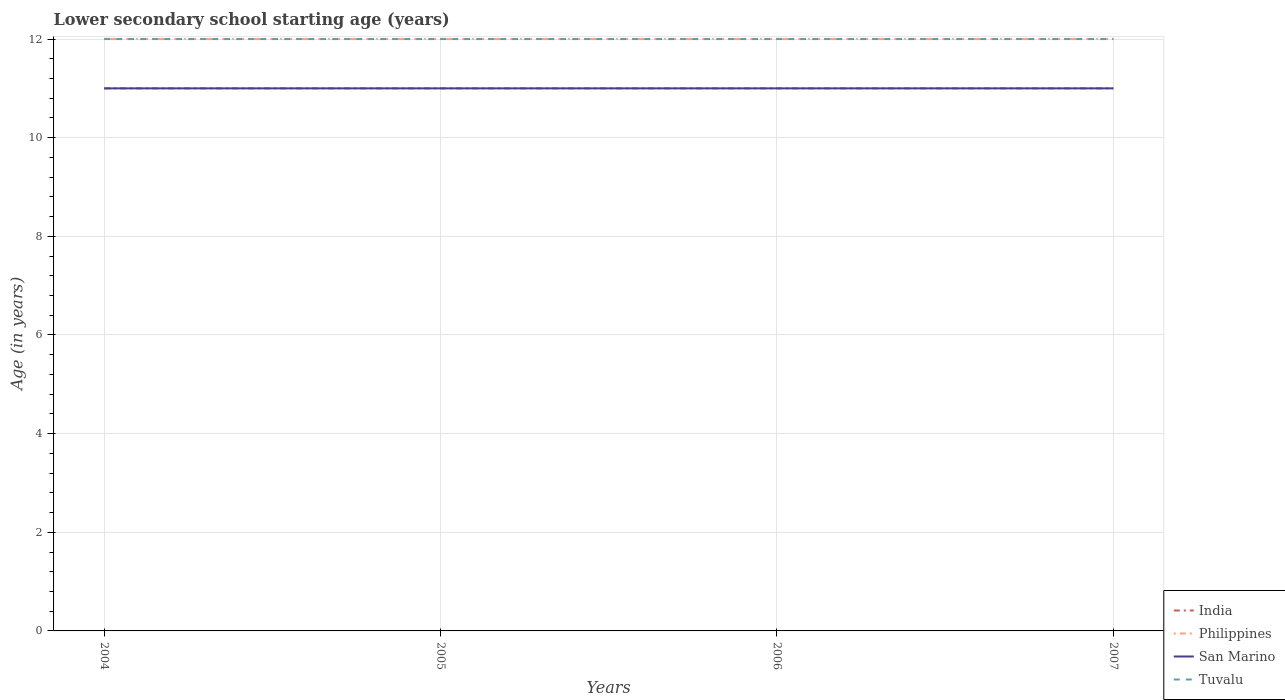How many different coloured lines are there?
Keep it short and to the point. 4. Is the number of lines equal to the number of legend labels?
Ensure brevity in your answer.  Yes. Across all years, what is the maximum lower secondary school starting age of children in India?
Make the answer very short. 11. What is the difference between the highest and the second highest lower secondary school starting age of children in San Marino?
Offer a terse response. 0. What is the difference between the highest and the lowest lower secondary school starting age of children in Tuvalu?
Give a very brief answer. 0. What is the difference between two consecutive major ticks on the Y-axis?
Your answer should be compact. 2. Does the graph contain grids?
Offer a very short reply. Yes. Where does the legend appear in the graph?
Provide a short and direct response. Bottom right. How many legend labels are there?
Your answer should be compact. 4. How are the legend labels stacked?
Provide a short and direct response. Vertical. What is the title of the graph?
Make the answer very short. Lower secondary school starting age (years). What is the label or title of the Y-axis?
Ensure brevity in your answer.  Age (in years). What is the Age (in years) in San Marino in 2004?
Offer a terse response. 11. What is the Age (in years) of Tuvalu in 2004?
Offer a very short reply. 12. What is the Age (in years) in Philippines in 2005?
Your answer should be compact. 12. What is the Age (in years) of India in 2006?
Provide a succinct answer. 11. What is the Age (in years) of Tuvalu in 2006?
Keep it short and to the point. 12. What is the Age (in years) of San Marino in 2007?
Provide a succinct answer. 11. What is the Age (in years) in Tuvalu in 2007?
Your answer should be very brief. 12. Across all years, what is the maximum Age (in years) of San Marino?
Make the answer very short. 11. Across all years, what is the maximum Age (in years) in Tuvalu?
Keep it short and to the point. 12. What is the total Age (in years) of India in the graph?
Ensure brevity in your answer.  44. What is the difference between the Age (in years) of India in 2004 and that in 2005?
Keep it short and to the point. 0. What is the difference between the Age (in years) in Philippines in 2004 and that in 2005?
Provide a short and direct response. 0. What is the difference between the Age (in years) of India in 2004 and that in 2006?
Your answer should be compact. 0. What is the difference between the Age (in years) in San Marino in 2004 and that in 2006?
Provide a short and direct response. 0. What is the difference between the Age (in years) in Philippines in 2004 and that in 2007?
Offer a terse response. 0. What is the difference between the Age (in years) in Tuvalu in 2004 and that in 2007?
Offer a terse response. 0. What is the difference between the Age (in years) of India in 2005 and that in 2006?
Offer a terse response. 0. What is the difference between the Age (in years) of Tuvalu in 2005 and that in 2006?
Provide a succinct answer. 0. What is the difference between the Age (in years) of Philippines in 2005 and that in 2007?
Provide a succinct answer. 0. What is the difference between the Age (in years) of Philippines in 2006 and that in 2007?
Your answer should be compact. 0. What is the difference between the Age (in years) of San Marino in 2006 and that in 2007?
Keep it short and to the point. 0. What is the difference between the Age (in years) of Tuvalu in 2006 and that in 2007?
Keep it short and to the point. 0. What is the difference between the Age (in years) of Philippines in 2004 and the Age (in years) of San Marino in 2005?
Your answer should be very brief. 1. What is the difference between the Age (in years) of Philippines in 2004 and the Age (in years) of Tuvalu in 2005?
Provide a short and direct response. 0. What is the difference between the Age (in years) of San Marino in 2004 and the Age (in years) of Tuvalu in 2005?
Your answer should be compact. -1. What is the difference between the Age (in years) of India in 2004 and the Age (in years) of Philippines in 2006?
Provide a succinct answer. -1. What is the difference between the Age (in years) of India in 2004 and the Age (in years) of San Marino in 2006?
Your answer should be compact. 0. What is the difference between the Age (in years) of Philippines in 2004 and the Age (in years) of Tuvalu in 2006?
Provide a succinct answer. 0. What is the difference between the Age (in years) in India in 2004 and the Age (in years) in Tuvalu in 2007?
Keep it short and to the point. -1. What is the difference between the Age (in years) in Philippines in 2004 and the Age (in years) in San Marino in 2007?
Your response must be concise. 1. What is the difference between the Age (in years) of India in 2005 and the Age (in years) of Philippines in 2006?
Ensure brevity in your answer.  -1. What is the difference between the Age (in years) of India in 2005 and the Age (in years) of San Marino in 2006?
Provide a succinct answer. 0. What is the difference between the Age (in years) in India in 2005 and the Age (in years) in Tuvalu in 2006?
Make the answer very short. -1. What is the difference between the Age (in years) in Philippines in 2005 and the Age (in years) in Tuvalu in 2006?
Keep it short and to the point. 0. What is the difference between the Age (in years) of India in 2005 and the Age (in years) of San Marino in 2007?
Ensure brevity in your answer.  0. What is the difference between the Age (in years) of San Marino in 2005 and the Age (in years) of Tuvalu in 2007?
Your answer should be compact. -1. What is the difference between the Age (in years) in India in 2006 and the Age (in years) in Philippines in 2007?
Ensure brevity in your answer.  -1. What is the difference between the Age (in years) in India in 2006 and the Age (in years) in Tuvalu in 2007?
Your response must be concise. -1. What is the difference between the Age (in years) in Philippines in 2006 and the Age (in years) in San Marino in 2007?
Keep it short and to the point. 1. What is the difference between the Age (in years) of Philippines in 2006 and the Age (in years) of Tuvalu in 2007?
Your response must be concise. 0. What is the difference between the Age (in years) in San Marino in 2006 and the Age (in years) in Tuvalu in 2007?
Provide a succinct answer. -1. What is the average Age (in years) of India per year?
Ensure brevity in your answer.  11. What is the average Age (in years) of San Marino per year?
Your answer should be very brief. 11. In the year 2004, what is the difference between the Age (in years) of India and Age (in years) of Philippines?
Offer a very short reply. -1. In the year 2004, what is the difference between the Age (in years) of Philippines and Age (in years) of Tuvalu?
Keep it short and to the point. 0. In the year 2004, what is the difference between the Age (in years) of San Marino and Age (in years) of Tuvalu?
Give a very brief answer. -1. In the year 2005, what is the difference between the Age (in years) of India and Age (in years) of Tuvalu?
Make the answer very short. -1. In the year 2005, what is the difference between the Age (in years) of Philippines and Age (in years) of San Marino?
Keep it short and to the point. 1. In the year 2005, what is the difference between the Age (in years) in San Marino and Age (in years) in Tuvalu?
Provide a succinct answer. -1. In the year 2006, what is the difference between the Age (in years) in India and Age (in years) in San Marino?
Offer a terse response. 0. In the year 2006, what is the difference between the Age (in years) in India and Age (in years) in Tuvalu?
Your answer should be compact. -1. In the year 2006, what is the difference between the Age (in years) in Philippines and Age (in years) in San Marino?
Your answer should be compact. 1. In the year 2006, what is the difference between the Age (in years) in San Marino and Age (in years) in Tuvalu?
Provide a succinct answer. -1. In the year 2007, what is the difference between the Age (in years) of India and Age (in years) of San Marino?
Your response must be concise. 0. In the year 2007, what is the difference between the Age (in years) of India and Age (in years) of Tuvalu?
Ensure brevity in your answer.  -1. In the year 2007, what is the difference between the Age (in years) of Philippines and Age (in years) of San Marino?
Your answer should be compact. 1. What is the ratio of the Age (in years) of India in 2004 to that in 2005?
Provide a short and direct response. 1. What is the ratio of the Age (in years) of San Marino in 2004 to that in 2005?
Give a very brief answer. 1. What is the ratio of the Age (in years) in Tuvalu in 2004 to that in 2005?
Ensure brevity in your answer.  1. What is the ratio of the Age (in years) in India in 2004 to that in 2006?
Give a very brief answer. 1. What is the ratio of the Age (in years) of San Marino in 2004 to that in 2006?
Provide a succinct answer. 1. What is the ratio of the Age (in years) of Philippines in 2004 to that in 2007?
Your answer should be compact. 1. What is the ratio of the Age (in years) in San Marino in 2004 to that in 2007?
Your answer should be compact. 1. What is the ratio of the Age (in years) in Tuvalu in 2004 to that in 2007?
Offer a terse response. 1. What is the ratio of the Age (in years) of India in 2005 to that in 2006?
Ensure brevity in your answer.  1. What is the ratio of the Age (in years) in Philippines in 2005 to that in 2006?
Offer a very short reply. 1. What is the ratio of the Age (in years) of San Marino in 2005 to that in 2006?
Provide a short and direct response. 1. What is the ratio of the Age (in years) of Tuvalu in 2005 to that in 2006?
Your answer should be very brief. 1. What is the ratio of the Age (in years) in India in 2005 to that in 2007?
Offer a terse response. 1. What is the ratio of the Age (in years) in Tuvalu in 2005 to that in 2007?
Offer a terse response. 1. What is the ratio of the Age (in years) of India in 2006 to that in 2007?
Provide a short and direct response. 1. What is the difference between the highest and the second highest Age (in years) of India?
Your response must be concise. 0. What is the difference between the highest and the second highest Age (in years) of Philippines?
Your answer should be very brief. 0. What is the difference between the highest and the second highest Age (in years) of San Marino?
Offer a very short reply. 0. What is the difference between the highest and the lowest Age (in years) in Philippines?
Offer a very short reply. 0. What is the difference between the highest and the lowest Age (in years) of Tuvalu?
Provide a short and direct response. 0. 